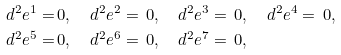Convert formula to latex. <formula><loc_0><loc_0><loc_500><loc_500>d ^ { 2 } e ^ { 1 } = & \, 0 , \quad d ^ { 2 } e ^ { 2 } = \, 0 , \quad d ^ { 2 } e ^ { 3 } = \, 0 , \quad d ^ { 2 } e ^ { 4 } = \, 0 , \\ d ^ { 2 } e ^ { 5 } = & \, 0 , \quad d ^ { 2 } e ^ { 6 } = \, 0 , \quad d ^ { 2 } e ^ { 7 } = \, 0 , \\</formula> 